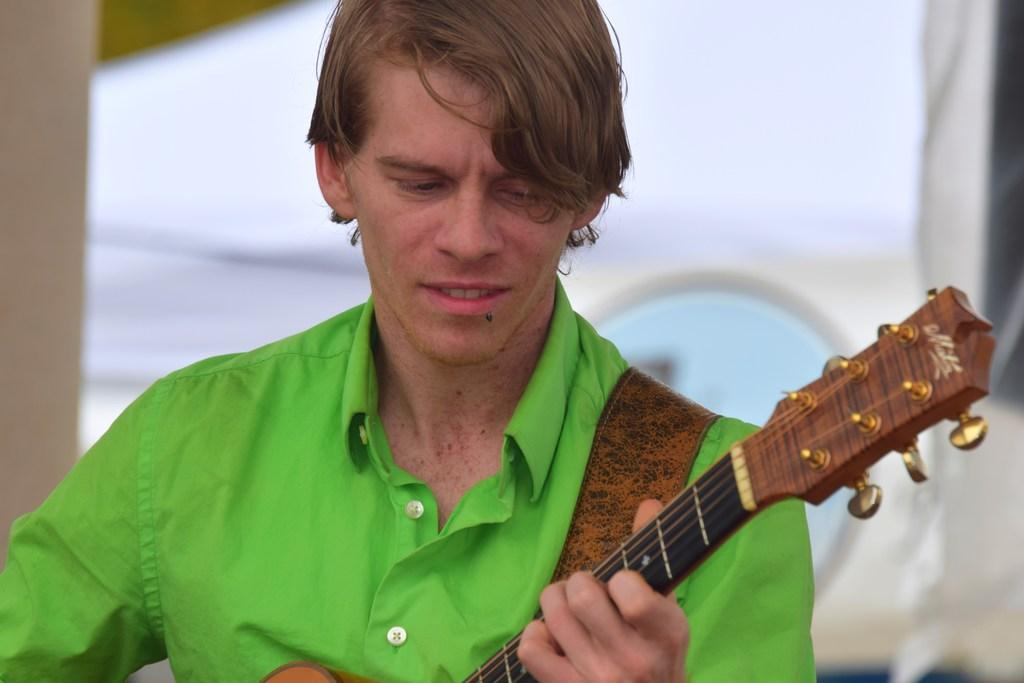What is the person in the image holding? The person is holding a guitar in the image. What can be seen in the background of the image? There is a wall in the background of the image. Are the police present in the image? No, there is no mention of police in the image. Can you see a group of people in the image? No, the image only features one person holding a guitar. 